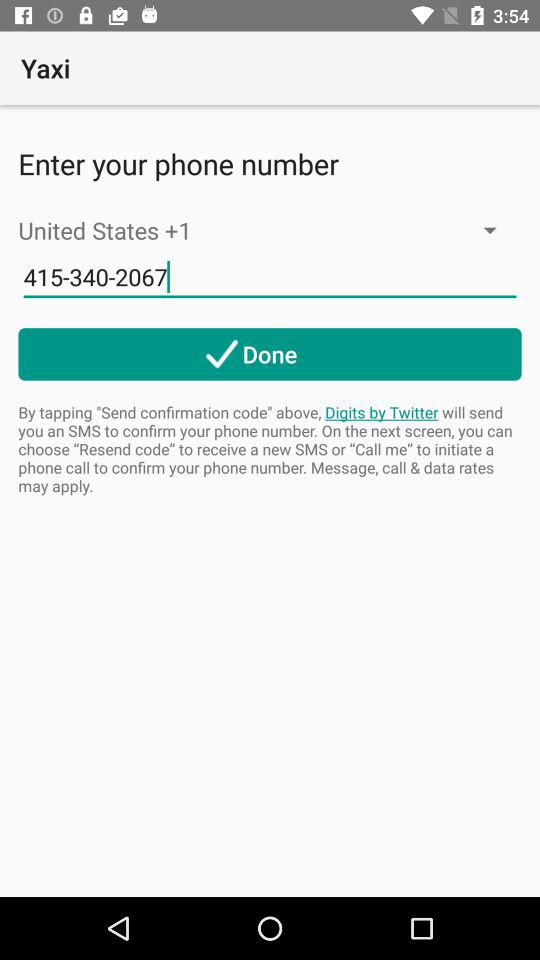What is the entered phone number? The entered phone number is 415-340-2067. 